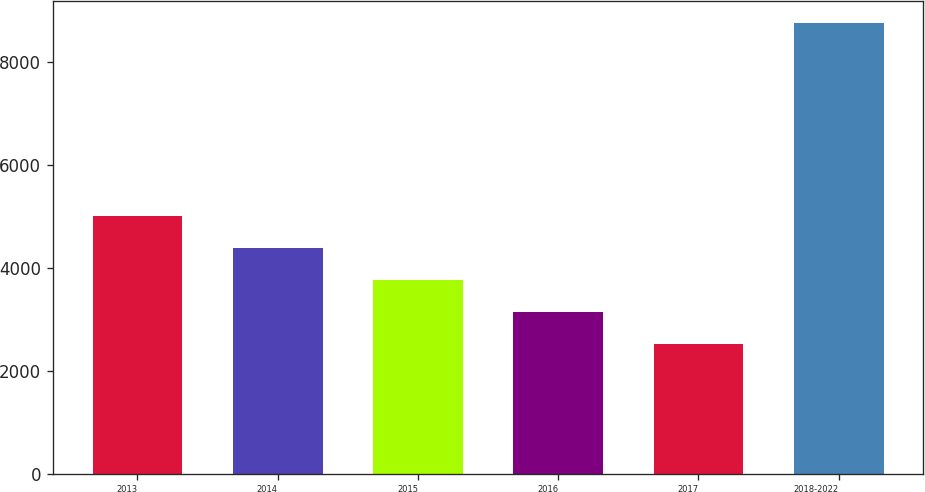Convert chart. <chart><loc_0><loc_0><loc_500><loc_500><bar_chart><fcel>2013<fcel>2014<fcel>2015<fcel>2016<fcel>2017<fcel>2018-2022<nl><fcel>5016.4<fcel>4392.8<fcel>3769.2<fcel>3145.6<fcel>2522<fcel>8758<nl></chart> 